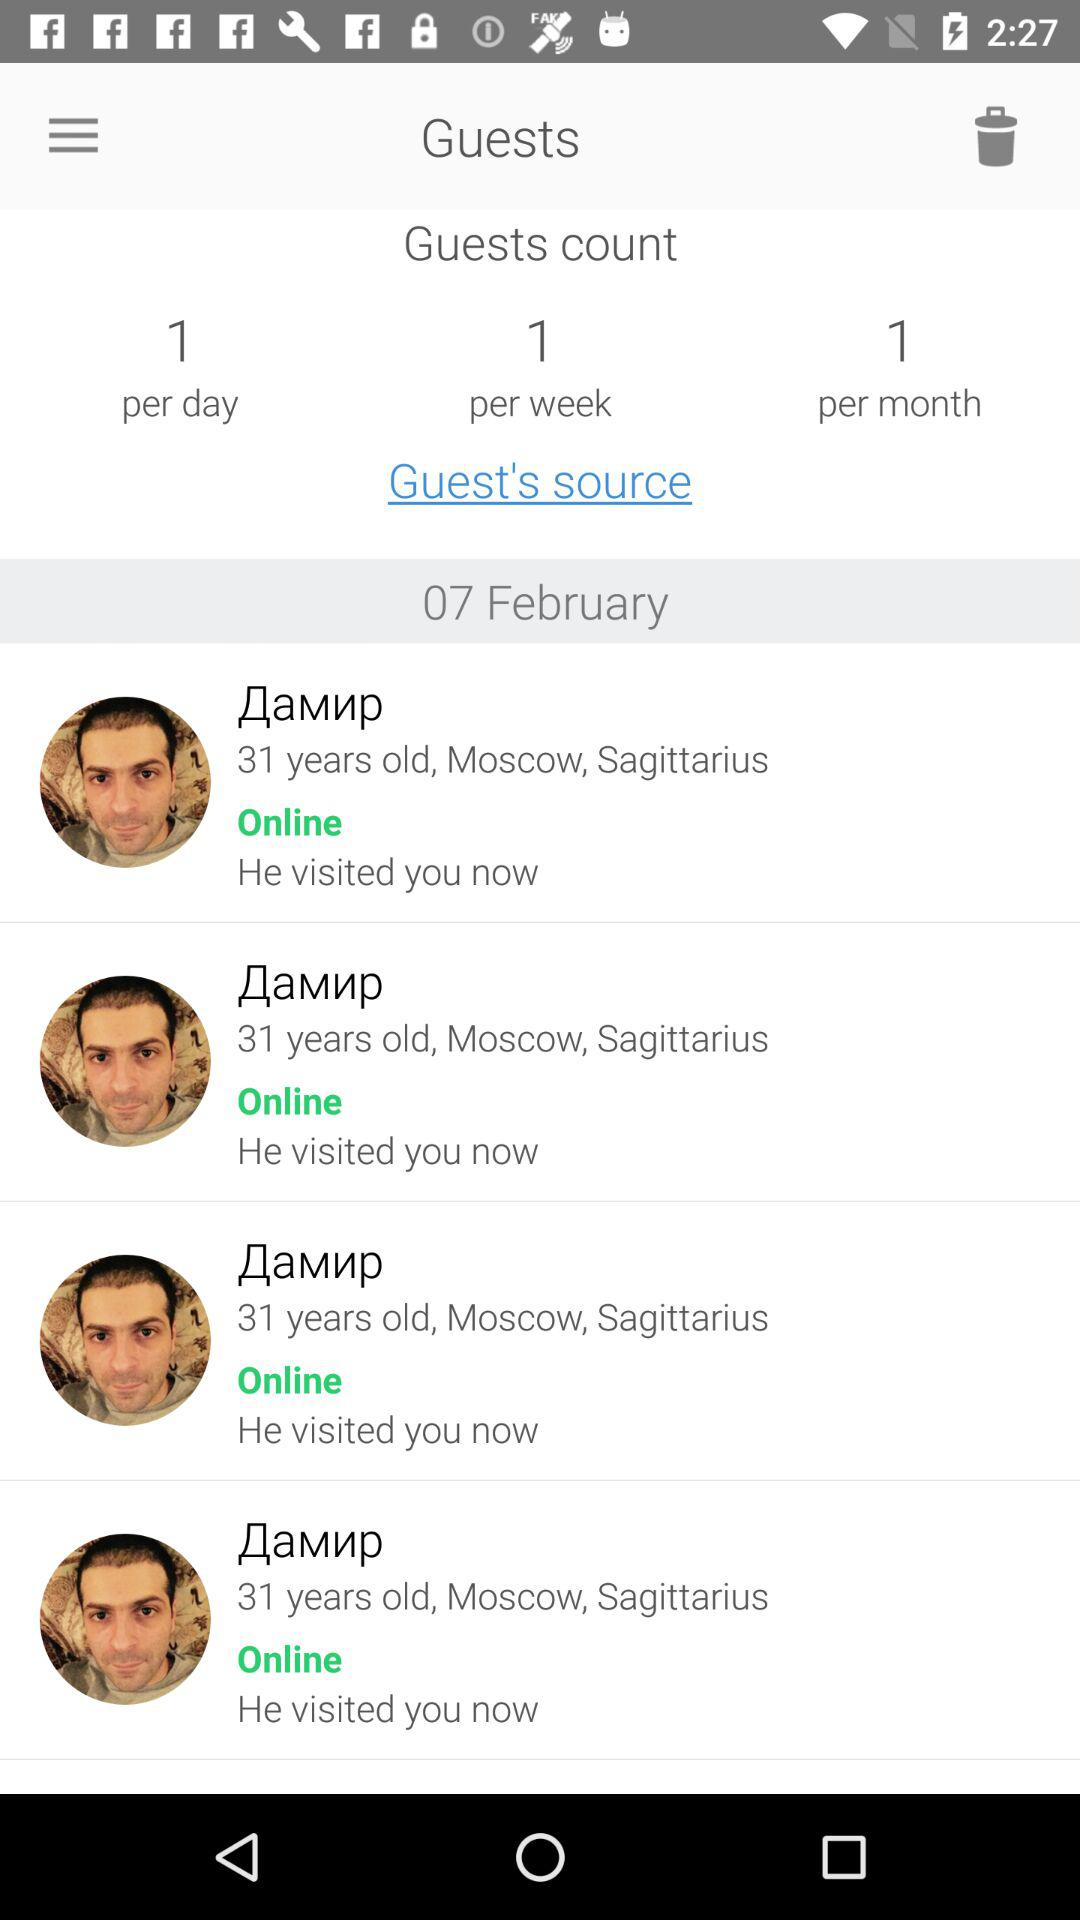What is the date? The date is February 7. 